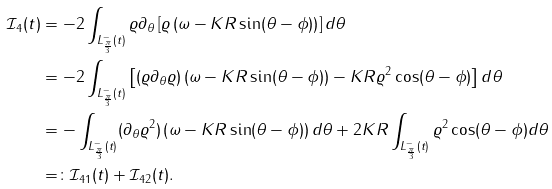Convert formula to latex. <formula><loc_0><loc_0><loc_500><loc_500>\mathcal { I } _ { 4 } ( t ) & = - 2 \int _ { L ^ { - } _ { \frac { \pi } { 3 } } ( t ) } \varrho \partial _ { \theta } \left [ \varrho \left ( \omega - K R \sin ( \theta - \phi ) \right ) \right ] d \theta \\ & = - 2 \int _ { L ^ { - } _ { \frac { \pi } { 3 } } ( t ) } \left [ ( \varrho \partial _ { \theta } \varrho ) \left ( \omega - K R \sin ( \theta - \phi ) \right ) - K R \varrho ^ { 2 } \cos ( \theta - \phi ) \right ] d \theta \\ & = - \int _ { L ^ { - } _ { \frac { \pi } { 3 } } ( t ) } ( \partial _ { \theta } \varrho ^ { 2 } ) \left ( \omega - K R \sin ( \theta - \phi ) \right ) d \theta + 2 K R \int _ { L ^ { - } _ { \frac { \pi } { 3 } } ( t ) } \varrho ^ { 2 } \cos ( \theta - \phi ) d \theta \\ & = \colon \mathcal { I } _ { 4 1 } ( t ) + \mathcal { I } _ { 4 2 } ( t ) .</formula> 